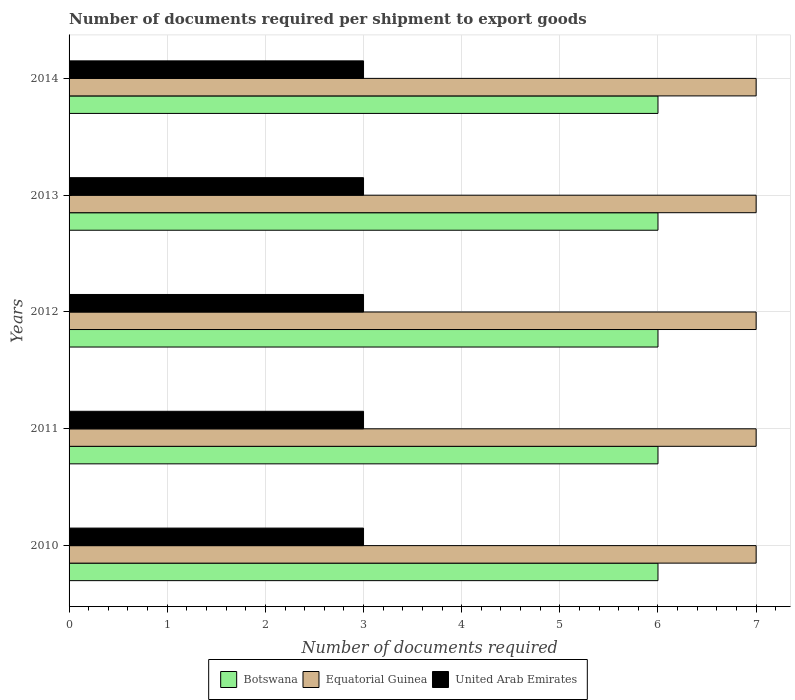How many different coloured bars are there?
Keep it short and to the point. 3. Are the number of bars on each tick of the Y-axis equal?
Provide a short and direct response. Yes. In how many cases, is the number of bars for a given year not equal to the number of legend labels?
Offer a terse response. 0. What is the number of documents required per shipment to export goods in Botswana in 2012?
Provide a succinct answer. 6. What is the total number of documents required per shipment to export goods in Equatorial Guinea in the graph?
Keep it short and to the point. 35. What is the difference between the number of documents required per shipment to export goods in United Arab Emirates in 2014 and the number of documents required per shipment to export goods in Botswana in 2012?
Offer a very short reply. -3. In the year 2014, what is the difference between the number of documents required per shipment to export goods in Botswana and number of documents required per shipment to export goods in United Arab Emirates?
Your response must be concise. 3. In how many years, is the number of documents required per shipment to export goods in United Arab Emirates greater than 6.8 ?
Provide a succinct answer. 0. What is the ratio of the number of documents required per shipment to export goods in Botswana in 2011 to that in 2013?
Make the answer very short. 1. Is the difference between the number of documents required per shipment to export goods in Botswana in 2010 and 2011 greater than the difference between the number of documents required per shipment to export goods in United Arab Emirates in 2010 and 2011?
Keep it short and to the point. No. What is the difference between the highest and the lowest number of documents required per shipment to export goods in Botswana?
Ensure brevity in your answer.  0. What does the 3rd bar from the top in 2012 represents?
Offer a very short reply. Botswana. What does the 2nd bar from the bottom in 2011 represents?
Your answer should be very brief. Equatorial Guinea. Is it the case that in every year, the sum of the number of documents required per shipment to export goods in Equatorial Guinea and number of documents required per shipment to export goods in Botswana is greater than the number of documents required per shipment to export goods in United Arab Emirates?
Make the answer very short. Yes. How many bars are there?
Make the answer very short. 15. Are all the bars in the graph horizontal?
Keep it short and to the point. Yes. How many years are there in the graph?
Your response must be concise. 5. Are the values on the major ticks of X-axis written in scientific E-notation?
Your answer should be very brief. No. Does the graph contain any zero values?
Make the answer very short. No. What is the title of the graph?
Your response must be concise. Number of documents required per shipment to export goods. What is the label or title of the X-axis?
Your answer should be very brief. Number of documents required. What is the Number of documents required of Equatorial Guinea in 2010?
Ensure brevity in your answer.  7. What is the Number of documents required in United Arab Emirates in 2010?
Your answer should be very brief. 3. What is the Number of documents required of Botswana in 2011?
Provide a short and direct response. 6. What is the Number of documents required in Equatorial Guinea in 2011?
Your answer should be very brief. 7. What is the Number of documents required of Botswana in 2013?
Offer a very short reply. 6. What is the Number of documents required in United Arab Emirates in 2013?
Provide a succinct answer. 3. What is the Number of documents required in Botswana in 2014?
Offer a terse response. 6. Across all years, what is the maximum Number of documents required of Botswana?
Offer a very short reply. 6. Across all years, what is the minimum Number of documents required of Botswana?
Offer a very short reply. 6. Across all years, what is the minimum Number of documents required of Equatorial Guinea?
Your answer should be compact. 7. What is the total Number of documents required in Botswana in the graph?
Offer a terse response. 30. What is the total Number of documents required of Equatorial Guinea in the graph?
Provide a succinct answer. 35. What is the total Number of documents required of United Arab Emirates in the graph?
Offer a very short reply. 15. What is the difference between the Number of documents required of Botswana in 2010 and that in 2011?
Give a very brief answer. 0. What is the difference between the Number of documents required in Equatorial Guinea in 2010 and that in 2011?
Your response must be concise. 0. What is the difference between the Number of documents required of United Arab Emirates in 2010 and that in 2011?
Provide a short and direct response. 0. What is the difference between the Number of documents required in Botswana in 2010 and that in 2012?
Your response must be concise. 0. What is the difference between the Number of documents required in United Arab Emirates in 2010 and that in 2012?
Offer a terse response. 0. What is the difference between the Number of documents required of Botswana in 2010 and that in 2014?
Make the answer very short. 0. What is the difference between the Number of documents required of Equatorial Guinea in 2010 and that in 2014?
Provide a succinct answer. 0. What is the difference between the Number of documents required of Equatorial Guinea in 2011 and that in 2012?
Ensure brevity in your answer.  0. What is the difference between the Number of documents required of United Arab Emirates in 2011 and that in 2012?
Your answer should be compact. 0. What is the difference between the Number of documents required in Botswana in 2011 and that in 2013?
Ensure brevity in your answer.  0. What is the difference between the Number of documents required in Equatorial Guinea in 2011 and that in 2013?
Make the answer very short. 0. What is the difference between the Number of documents required in Botswana in 2011 and that in 2014?
Your answer should be very brief. 0. What is the difference between the Number of documents required in United Arab Emirates in 2011 and that in 2014?
Your answer should be very brief. 0. What is the difference between the Number of documents required of Botswana in 2012 and that in 2013?
Provide a short and direct response. 0. What is the difference between the Number of documents required in United Arab Emirates in 2012 and that in 2013?
Your answer should be compact. 0. What is the difference between the Number of documents required of United Arab Emirates in 2012 and that in 2014?
Your answer should be compact. 0. What is the difference between the Number of documents required in Botswana in 2013 and that in 2014?
Keep it short and to the point. 0. What is the difference between the Number of documents required in Botswana in 2010 and the Number of documents required in Equatorial Guinea in 2011?
Ensure brevity in your answer.  -1. What is the difference between the Number of documents required in Equatorial Guinea in 2010 and the Number of documents required in United Arab Emirates in 2011?
Offer a very short reply. 4. What is the difference between the Number of documents required of Botswana in 2010 and the Number of documents required of Equatorial Guinea in 2012?
Make the answer very short. -1. What is the difference between the Number of documents required of Botswana in 2010 and the Number of documents required of United Arab Emirates in 2012?
Ensure brevity in your answer.  3. What is the difference between the Number of documents required of Equatorial Guinea in 2010 and the Number of documents required of United Arab Emirates in 2012?
Provide a succinct answer. 4. What is the difference between the Number of documents required of Equatorial Guinea in 2010 and the Number of documents required of United Arab Emirates in 2013?
Your answer should be very brief. 4. What is the difference between the Number of documents required in Botswana in 2010 and the Number of documents required in Equatorial Guinea in 2014?
Give a very brief answer. -1. What is the difference between the Number of documents required in Equatorial Guinea in 2010 and the Number of documents required in United Arab Emirates in 2014?
Your answer should be very brief. 4. What is the difference between the Number of documents required of Botswana in 2011 and the Number of documents required of Equatorial Guinea in 2012?
Your answer should be very brief. -1. What is the difference between the Number of documents required in Botswana in 2011 and the Number of documents required in United Arab Emirates in 2012?
Offer a terse response. 3. What is the difference between the Number of documents required in Equatorial Guinea in 2011 and the Number of documents required in United Arab Emirates in 2012?
Your answer should be compact. 4. What is the difference between the Number of documents required in Botswana in 2011 and the Number of documents required in Equatorial Guinea in 2013?
Offer a terse response. -1. What is the difference between the Number of documents required of Botswana in 2011 and the Number of documents required of United Arab Emirates in 2013?
Offer a very short reply. 3. What is the difference between the Number of documents required in Botswana in 2012 and the Number of documents required in United Arab Emirates in 2014?
Give a very brief answer. 3. What is the difference between the Number of documents required of Botswana in 2013 and the Number of documents required of Equatorial Guinea in 2014?
Make the answer very short. -1. What is the difference between the Number of documents required in Equatorial Guinea in 2013 and the Number of documents required in United Arab Emirates in 2014?
Ensure brevity in your answer.  4. What is the average Number of documents required in Equatorial Guinea per year?
Your answer should be compact. 7. What is the average Number of documents required in United Arab Emirates per year?
Offer a terse response. 3. In the year 2010, what is the difference between the Number of documents required of Botswana and Number of documents required of United Arab Emirates?
Your answer should be compact. 3. In the year 2010, what is the difference between the Number of documents required of Equatorial Guinea and Number of documents required of United Arab Emirates?
Offer a very short reply. 4. In the year 2011, what is the difference between the Number of documents required in Botswana and Number of documents required in Equatorial Guinea?
Your answer should be very brief. -1. In the year 2011, what is the difference between the Number of documents required in Equatorial Guinea and Number of documents required in United Arab Emirates?
Your answer should be compact. 4. In the year 2012, what is the difference between the Number of documents required in Botswana and Number of documents required in United Arab Emirates?
Offer a terse response. 3. In the year 2012, what is the difference between the Number of documents required of Equatorial Guinea and Number of documents required of United Arab Emirates?
Your response must be concise. 4. In the year 2013, what is the difference between the Number of documents required of Botswana and Number of documents required of Equatorial Guinea?
Your response must be concise. -1. In the year 2013, what is the difference between the Number of documents required in Botswana and Number of documents required in United Arab Emirates?
Offer a very short reply. 3. In the year 2014, what is the difference between the Number of documents required of Botswana and Number of documents required of United Arab Emirates?
Make the answer very short. 3. What is the ratio of the Number of documents required in Botswana in 2010 to that in 2011?
Offer a very short reply. 1. What is the ratio of the Number of documents required of Equatorial Guinea in 2010 to that in 2012?
Offer a very short reply. 1. What is the ratio of the Number of documents required of United Arab Emirates in 2010 to that in 2012?
Offer a terse response. 1. What is the ratio of the Number of documents required of United Arab Emirates in 2010 to that in 2013?
Offer a terse response. 1. What is the ratio of the Number of documents required in Botswana in 2010 to that in 2014?
Provide a succinct answer. 1. What is the ratio of the Number of documents required in Equatorial Guinea in 2010 to that in 2014?
Your response must be concise. 1. What is the ratio of the Number of documents required in Botswana in 2011 to that in 2012?
Offer a very short reply. 1. What is the ratio of the Number of documents required of Equatorial Guinea in 2011 to that in 2012?
Your answer should be compact. 1. What is the ratio of the Number of documents required of Equatorial Guinea in 2011 to that in 2013?
Ensure brevity in your answer.  1. What is the ratio of the Number of documents required of Equatorial Guinea in 2012 to that in 2013?
Your response must be concise. 1. What is the ratio of the Number of documents required of United Arab Emirates in 2012 to that in 2014?
Your answer should be compact. 1. What is the ratio of the Number of documents required in Botswana in 2013 to that in 2014?
Provide a succinct answer. 1. What is the difference between the highest and the second highest Number of documents required of Equatorial Guinea?
Your answer should be compact. 0. What is the difference between the highest and the lowest Number of documents required of Equatorial Guinea?
Offer a terse response. 0. What is the difference between the highest and the lowest Number of documents required of United Arab Emirates?
Offer a terse response. 0. 